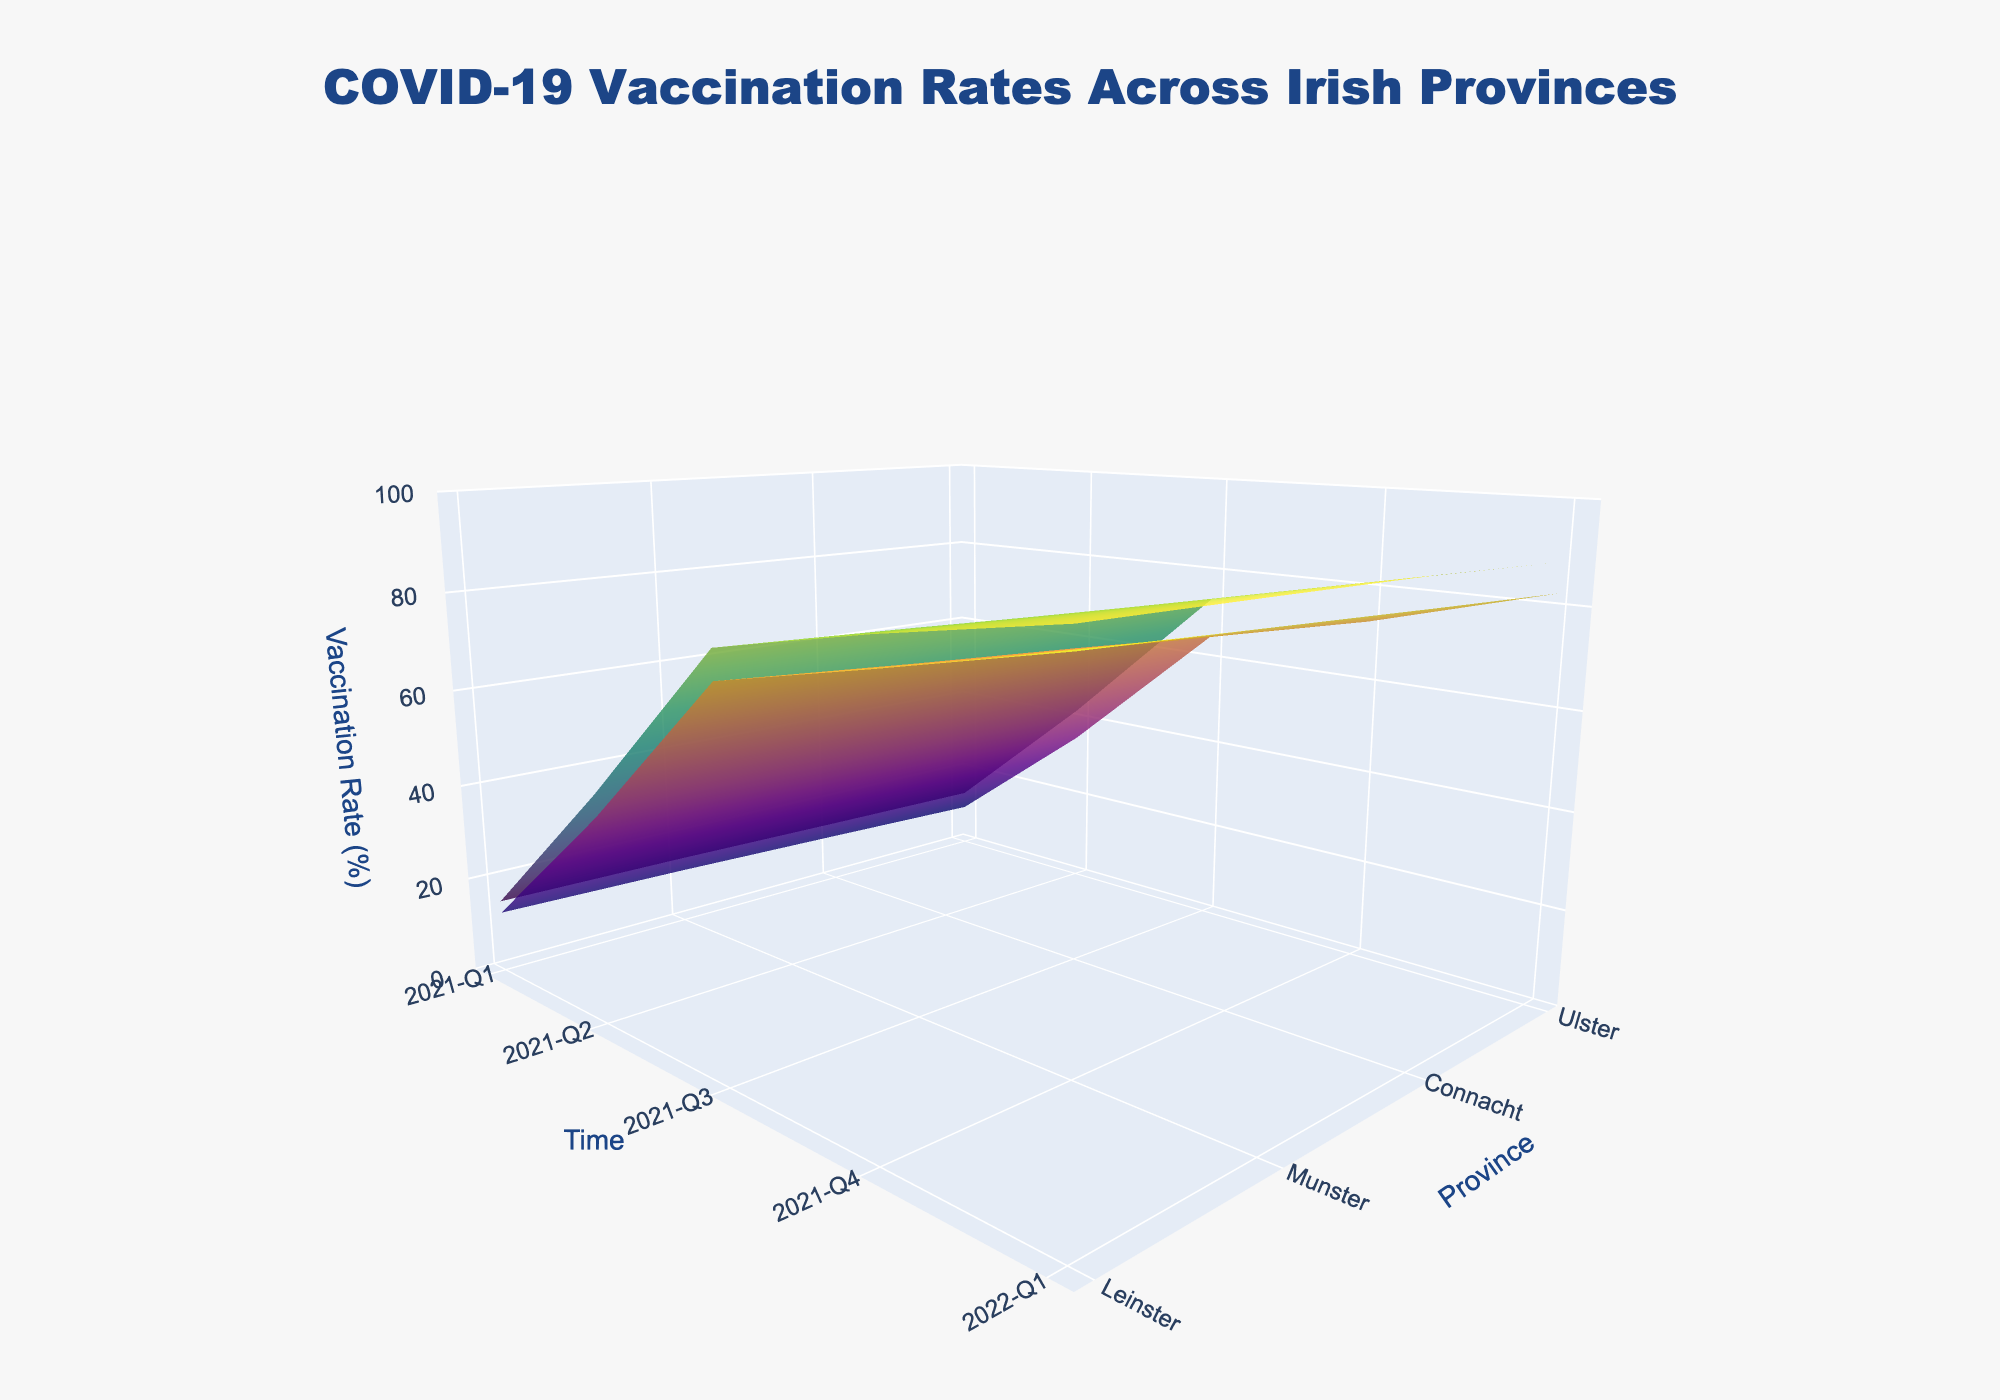What's the title of the plot? The title is located at the top of the plot. It reads "COVID-19 Vaccination Rates Across Irish Provinces."
Answer: COVID-19 Vaccination Rates Across Irish Provinces Which axis represents the different provinces of Ireland? The y-axis represents different provinces, as indicated by the labels for Leinster, Munster, Connacht, and Ulster.
Answer: y-axis How are the urban and rural areas differentiated in the plot? The urban and rural areas are differentiated by the colorscale used: 'Viridis' for Urban and 'Plasma' for Rural as well as the legend's title "Urban/Rural."
Answer: Colorscale Which province has the highest vaccination rate by the end of 2022-Q1 in urban areas? By locating the Urban surface for 2022-Q1 and finding the highest point, we see that Leinster has the highest vaccination rate in urban areas, marked as approximately 91.2.
Answer: Leinster Compare the vaccination rates between rural and urban areas in Munster during 2021-Q2. Which one is higher? We look at Munster's Urban and Rural surfaces for 2021-Q2. Urban is at 44.6 while Rural is 39.8, making Urban higher.
Answer: Urban Between Ulster and Connacht, which province had more significant growth in rural vaccination rates from 2021-Q1 to 2022-Q1? We find the differences for Ulster (82.4 - 9.6 = 72.8) and Connacht (84.1 - 10.8 = 73.3). Connacht shows a slightly greater increase than Ulster.
Answer: Connacht What is the overall trend in vaccination rates from 2021-Q1 to 2022-Q1 across all provinces and areas? The overall trend from 2021-Q1 to 2022-Q1 shows a steady increase in vaccination rates for all provinces and areas, gradually moving upwards as demonstrated by the surface slopes.
Answer: Steady increase In terms of vaccination rates, did any province achieve complete vaccination (100%) by 2022-Q1? By inspecting the z-axis values for 2022-Q1, no province reached a vaccination rate of 100% as the highest values are around 91.2-87.6.
Answer: No How does the vaccination rate trend for Leinster rural areas compare to Leinster urban areas across all quarters? The trend for Leinster shows that both areas exhibit a steady increase, with urban areas consistently having slightly higher vaccination rates in each quarter compared to rural areas.
Answer: Urban higher 